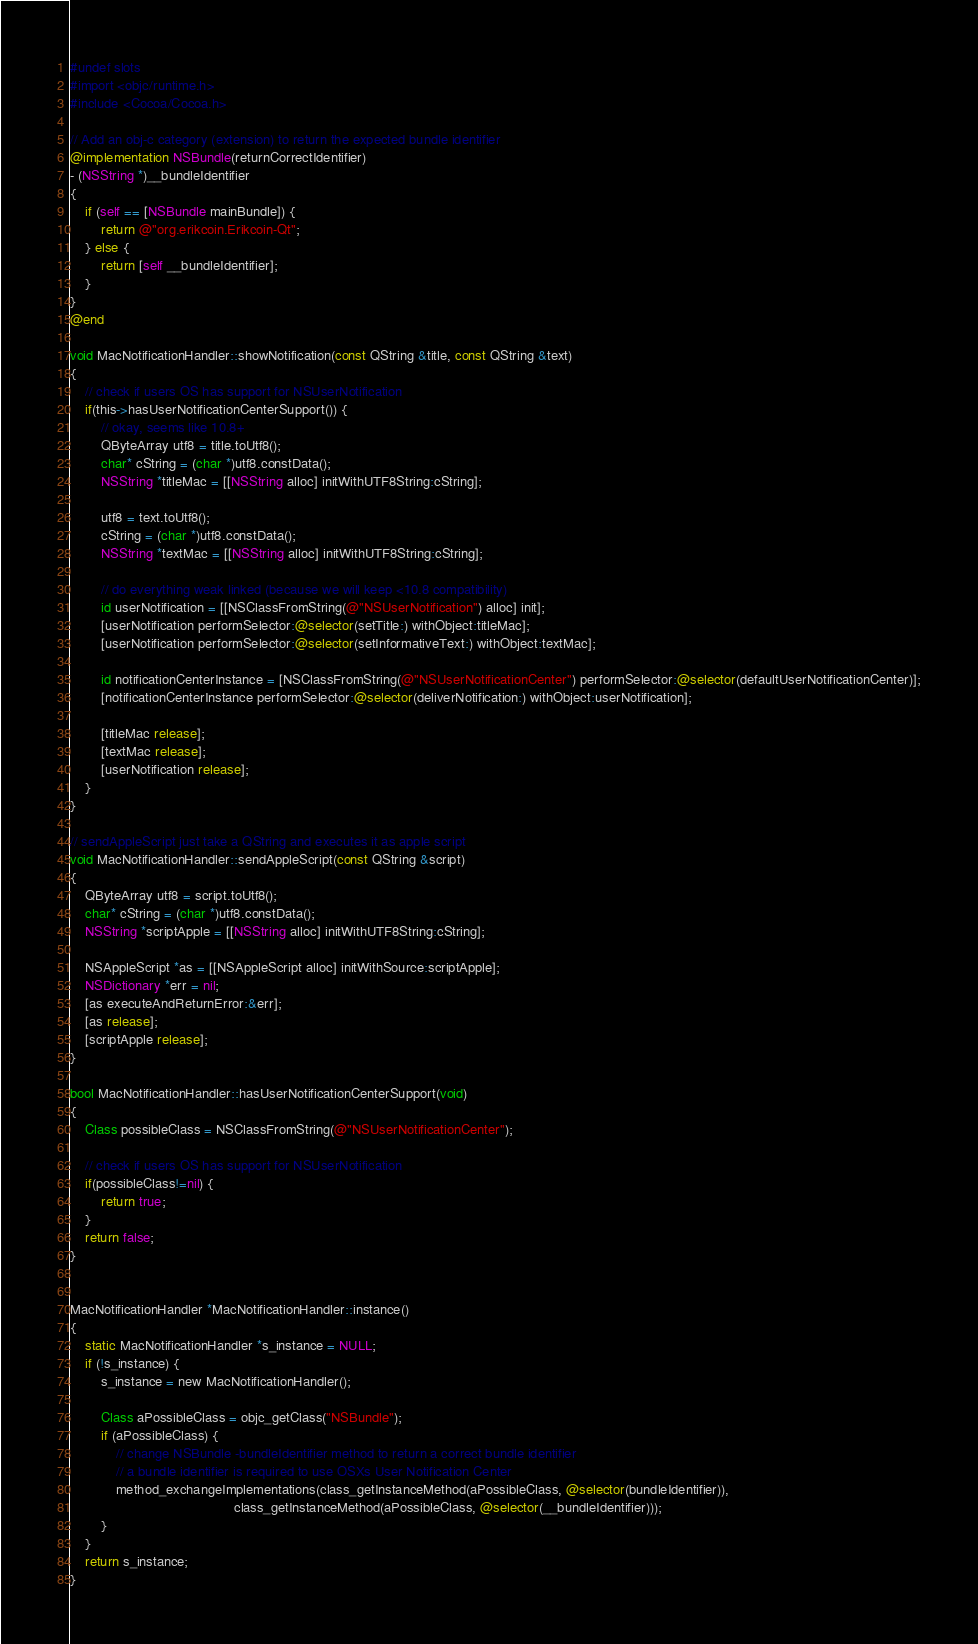Convert code to text. <code><loc_0><loc_0><loc_500><loc_500><_ObjectiveC_>#undef slots
#import <objc/runtime.h>
#include <Cocoa/Cocoa.h>

// Add an obj-c category (extension) to return the expected bundle identifier
@implementation NSBundle(returnCorrectIdentifier)
- (NSString *)__bundleIdentifier
{
    if (self == [NSBundle mainBundle]) {
        return @"org.erikcoin.Erikcoin-Qt";
    } else {
        return [self __bundleIdentifier];
    }
}
@end

void MacNotificationHandler::showNotification(const QString &title, const QString &text)
{
    // check if users OS has support for NSUserNotification
    if(this->hasUserNotificationCenterSupport()) {
        // okay, seems like 10.8+
        QByteArray utf8 = title.toUtf8();
        char* cString = (char *)utf8.constData();
        NSString *titleMac = [[NSString alloc] initWithUTF8String:cString];

        utf8 = text.toUtf8();
        cString = (char *)utf8.constData();
        NSString *textMac = [[NSString alloc] initWithUTF8String:cString];

        // do everything weak linked (because we will keep <10.8 compatibility)
        id userNotification = [[NSClassFromString(@"NSUserNotification") alloc] init];
        [userNotification performSelector:@selector(setTitle:) withObject:titleMac];
        [userNotification performSelector:@selector(setInformativeText:) withObject:textMac];

        id notificationCenterInstance = [NSClassFromString(@"NSUserNotificationCenter") performSelector:@selector(defaultUserNotificationCenter)];
        [notificationCenterInstance performSelector:@selector(deliverNotification:) withObject:userNotification];

        [titleMac release];
        [textMac release];
        [userNotification release];
    }
}

// sendAppleScript just take a QString and executes it as apple script
void MacNotificationHandler::sendAppleScript(const QString &script)
{
    QByteArray utf8 = script.toUtf8();
    char* cString = (char *)utf8.constData();
    NSString *scriptApple = [[NSString alloc] initWithUTF8String:cString];

    NSAppleScript *as = [[NSAppleScript alloc] initWithSource:scriptApple];
    NSDictionary *err = nil;
    [as executeAndReturnError:&err];
    [as release];
    [scriptApple release];
}

bool MacNotificationHandler::hasUserNotificationCenterSupport(void)
{
    Class possibleClass = NSClassFromString(@"NSUserNotificationCenter");

    // check if users OS has support for NSUserNotification
    if(possibleClass!=nil) {
        return true;
    }
    return false;
}


MacNotificationHandler *MacNotificationHandler::instance()
{
    static MacNotificationHandler *s_instance = NULL;
    if (!s_instance) {
        s_instance = new MacNotificationHandler();
        
        Class aPossibleClass = objc_getClass("NSBundle");
        if (aPossibleClass) {
            // change NSBundle -bundleIdentifier method to return a correct bundle identifier
            // a bundle identifier is required to use OSXs User Notification Center
            method_exchangeImplementations(class_getInstanceMethod(aPossibleClass, @selector(bundleIdentifier)),
                                           class_getInstanceMethod(aPossibleClass, @selector(__bundleIdentifier)));
        }
    }
    return s_instance;
}
</code> 